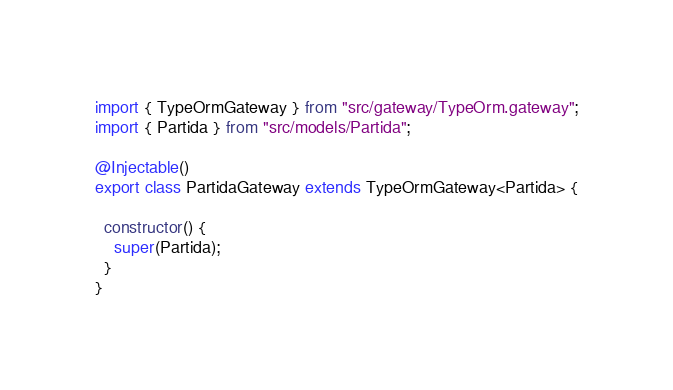Convert code to text. <code><loc_0><loc_0><loc_500><loc_500><_TypeScript_>import { TypeOrmGateway } from "src/gateway/TypeOrm.gateway";
import { Partida } from "src/models/Partida";

@Injectable()
export class PartidaGateway extends TypeOrmGateway<Partida> {

  constructor() {
    super(Partida);
  }
}</code> 